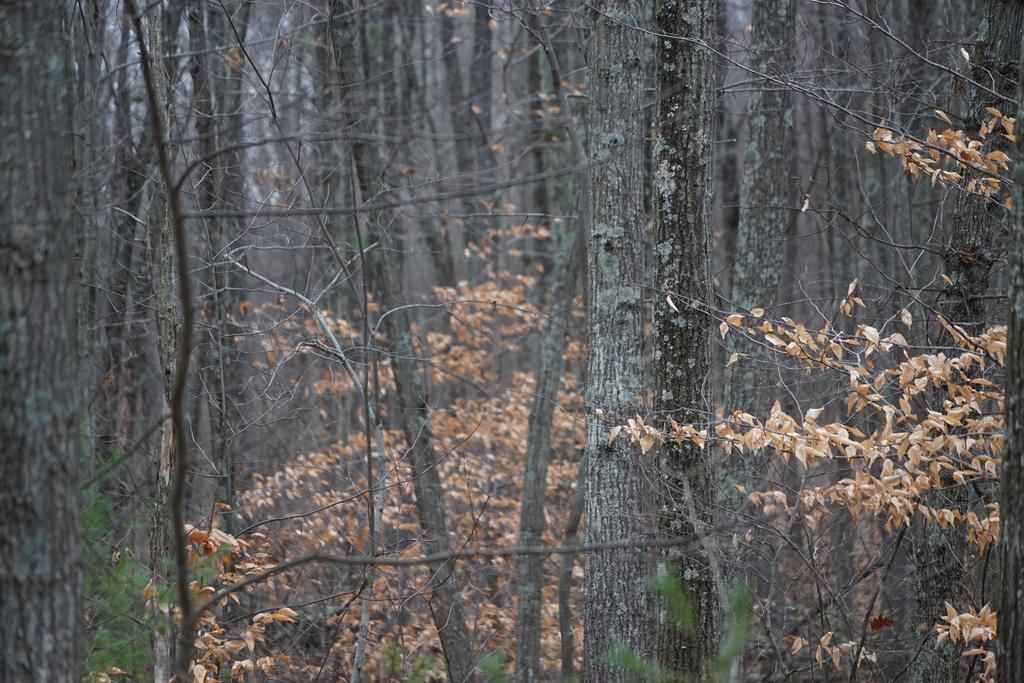In one or two sentences, can you explain what this image depicts? In this image, I can see tree trunks, grass and the sky. This image taken, maybe in the forest. 